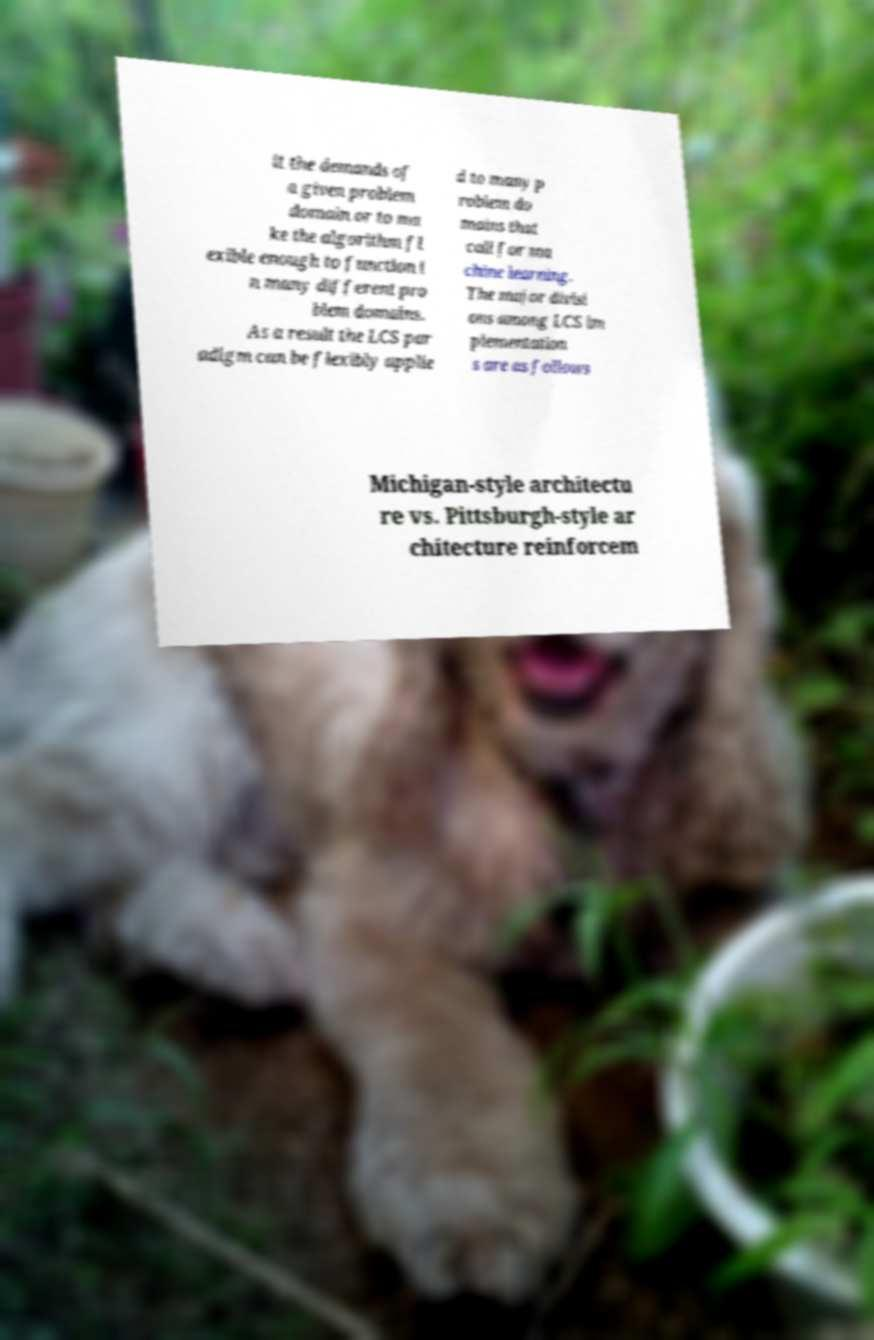There's text embedded in this image that I need extracted. Can you transcribe it verbatim? it the demands of a given problem domain or to ma ke the algorithm fl exible enough to function i n many different pro blem domains. As a result the LCS par adigm can be flexibly applie d to many p roblem do mains that call for ma chine learning. The major divisi ons among LCS im plementation s are as follows Michigan-style architectu re vs. Pittsburgh-style ar chitecture reinforcem 